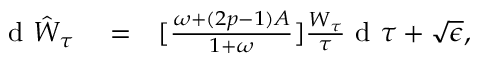Convert formula to latex. <formula><loc_0><loc_0><loc_500><loc_500>\begin{array} { r l r } { d \hat { W } _ { \tau } } & = } & { [ \frac { \omega + ( 2 p - 1 ) A } { 1 + \omega } ] \frac { W _ { \tau } } { \tau } d \tau + \sqrt { \epsilon } , } \end{array}</formula> 